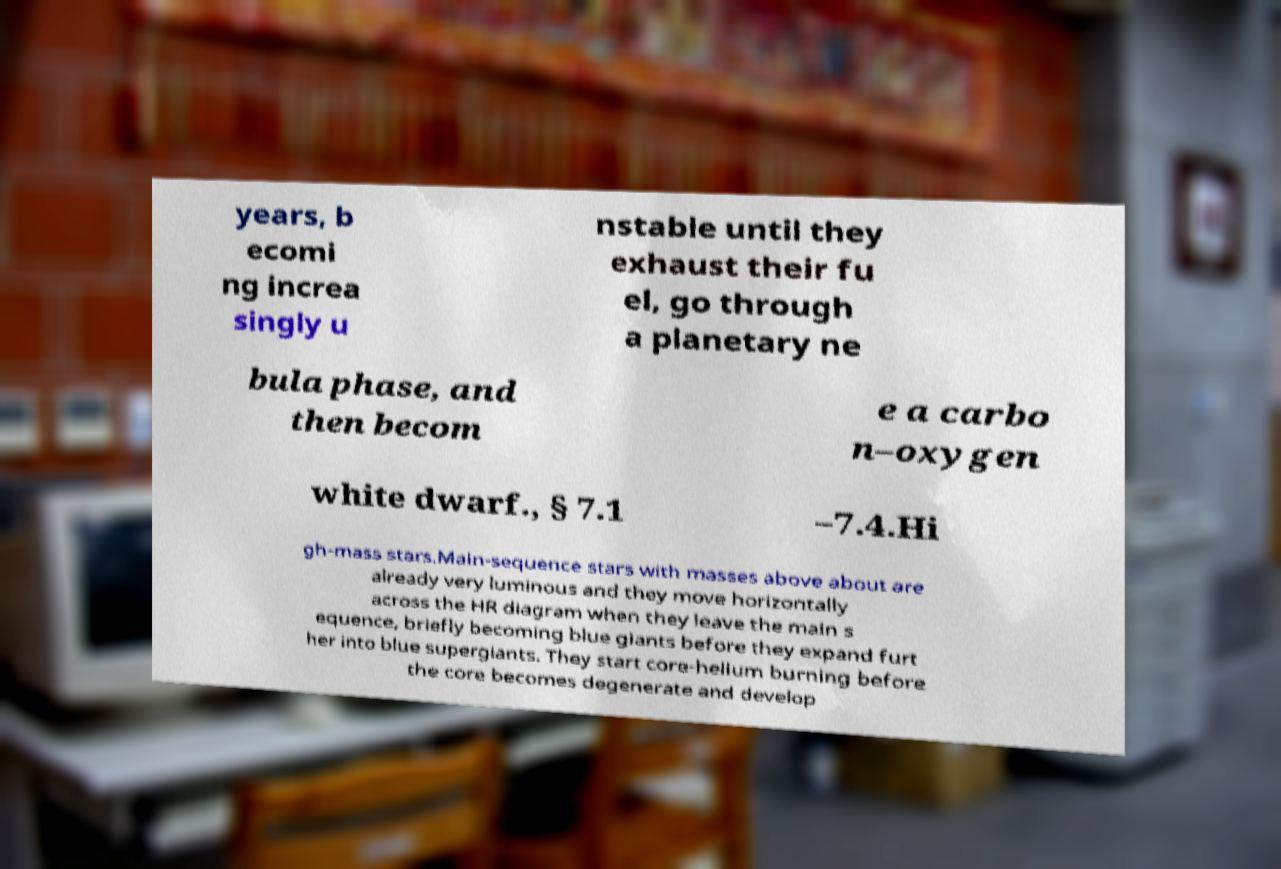Please identify and transcribe the text found in this image. years, b ecomi ng increa singly u nstable until they exhaust their fu el, go through a planetary ne bula phase, and then becom e a carbo n–oxygen white dwarf., § 7.1 –7.4.Hi gh-mass stars.Main-sequence stars with masses above about are already very luminous and they move horizontally across the HR diagram when they leave the main s equence, briefly becoming blue giants before they expand furt her into blue supergiants. They start core-helium burning before the core becomes degenerate and develop 